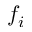<formula> <loc_0><loc_0><loc_500><loc_500>f _ { i }</formula> 